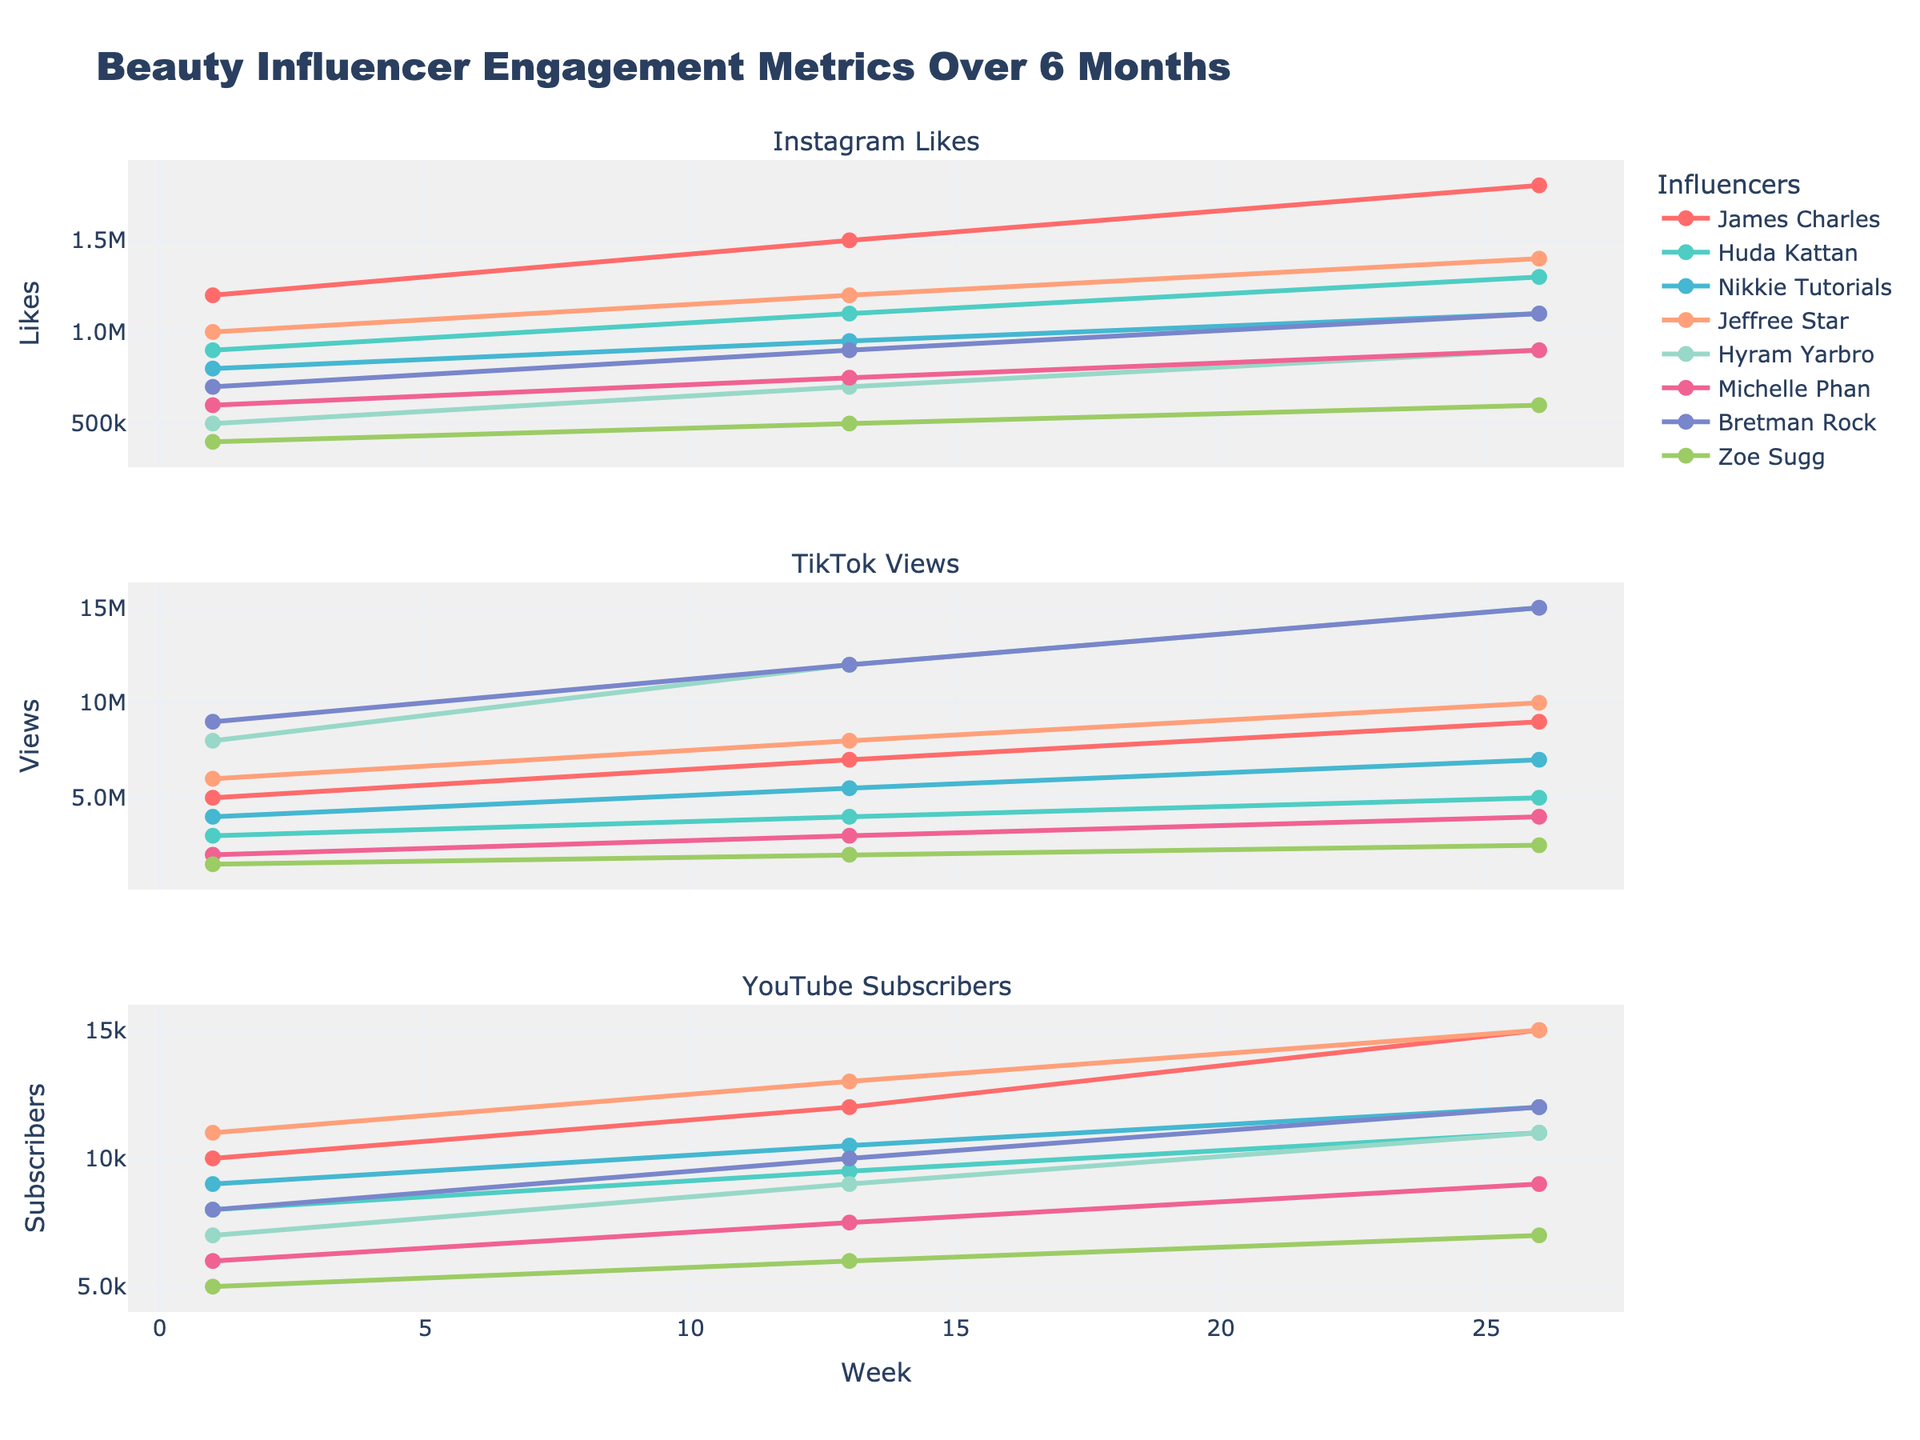Which influencer had the highest TikTok views at week 26? First, identify the TikTok views for all influencers at week 26. The values are: James Charles (9M), Huda Kattan (5M), Nikkie Tutorials (7M), Jeffree Star (10M), Hyram Yarbro (15M), Michelle Phan (4M), Bretman Rock (15M), Zoe Sugg (2.5M). The largest value is 15M from Hyram Yarbro and Bretman Rock.
Answer: Hyram Yarbro, Bretman Rock What is the difference in YouTube subscribers between James Charles and Nikkie Tutorials at week 26? Find the YouTube subscribers for James Charles and Nikkie Tutorials at week 26: James Charles (15K) and Nikkie Tutorials (12K). Subtract the two values: 15,000 - 12,000 = 3,000
Answer: 3,000 Which influencer had the least increase in Instagram likes from week 1 to week 26? Calculate the increase in Instagram likes from week 1 to week 26 for each influencer: James Charles (1.2M to 1.8M = 600K), Huda Kattan (900K to 1.3M = 400K), Nikkie Tutorials (800K to 1.1M = 300K), Jeffree Star (1M to 1.4M = 400K), Hyram Yarbro (500K to 900K = 400K), Michelle Phan (600K to 900K = 300K), Bretman Rock (700K to 1.1M = 400K), Zoe Sugg (400K to 600K = 200K). The smallest increase is Zoe Sugg with 200K.
Answer: Zoe Sugg Which influencers show an equal number of YouTube subscribers at week 26? Check the YouTube subscribers for all influencers at week 26: James Charles (15K), Huda Kattan (11K), Nikkie Tutorials (12K), Jeffree Star (15K), Hyram Yarbro (11K), Michelle Phan (9K), Bretman Rock (12K), Zoe Sugg (7K). The pairs with equal values are: James Charles & Jeffree Star (15K) and Nikkie Tutorials & Bretman Rock (12K).
Answer: James Charles & Jeffree Star; Nikkie Tutorials & Bretman Rock Who had more Instagram likes at week 13, Jeffree Star or Huda Kattan? Look at the Instagram likes for Jeffree Star and Huda Kattan at week 13. Jeffree Star had 1,200,000 likes and Huda Kattan had 1,100,000 likes. Therefore, Jeffree Star had more.
Answer: Jeffree Star What is the average TikTok views for Michelle Phan across all weeks? Calculate the average TikTok views for Michelle Phan: (2,000,000 + 3,000,000 + 4,000,000) / 3 = 3,000,000 views.
Answer: 3,000,000 Which influencer had a steady increase in all metrics over the 26 weeks? Review the data to check if the metrics for each influencer consistently increased from week 1 to week 26. James Charles, Huda Kattan, Nikkie Tutorials, Jeffree Star, Hyram Yarbro, Michelle Phan, Bretman Rock, and Zoe Sugg all show steady increases in Instagram Likes, TikTok Views, and YouTube Subscribers. Therefore, all these influencers had steady increases.
Answer: All influencers 